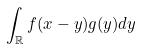<formula> <loc_0><loc_0><loc_500><loc_500>\int _ { \mathbb { R } } f ( x - y ) g ( y ) d y</formula> 